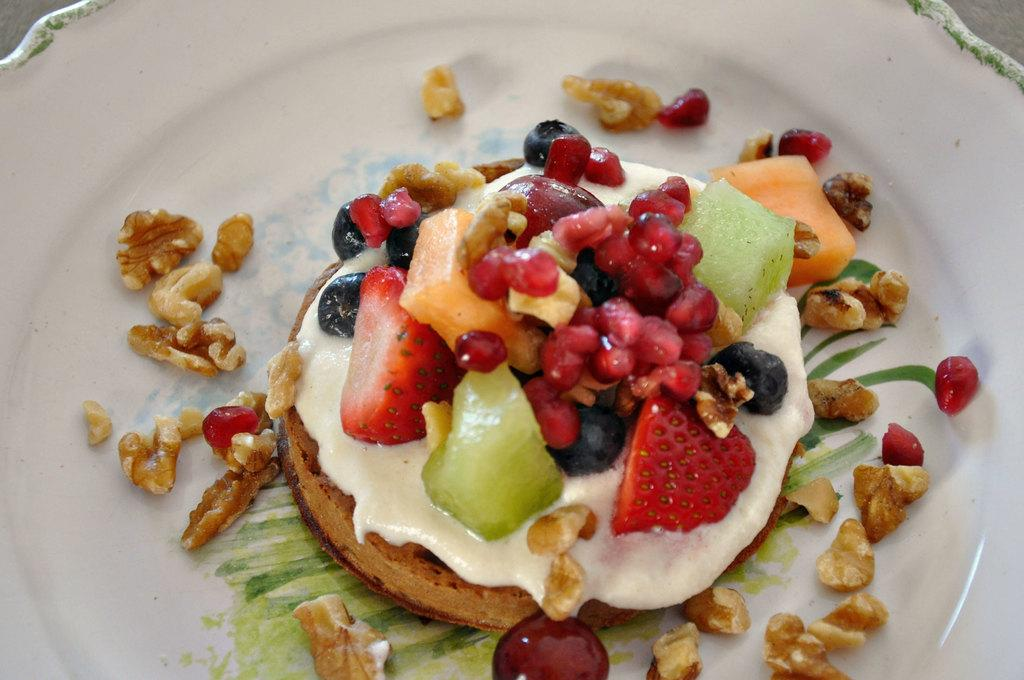What is on the plate that is visible in the image? There is food on a plate in the image. What color is the plate? The plate is white in color. What is depicted on the plate? There is a painting on the plate. How many chains can be seen attached to the food on the plate? There are no chains present in the image, as it features a plate with food and a painting. 